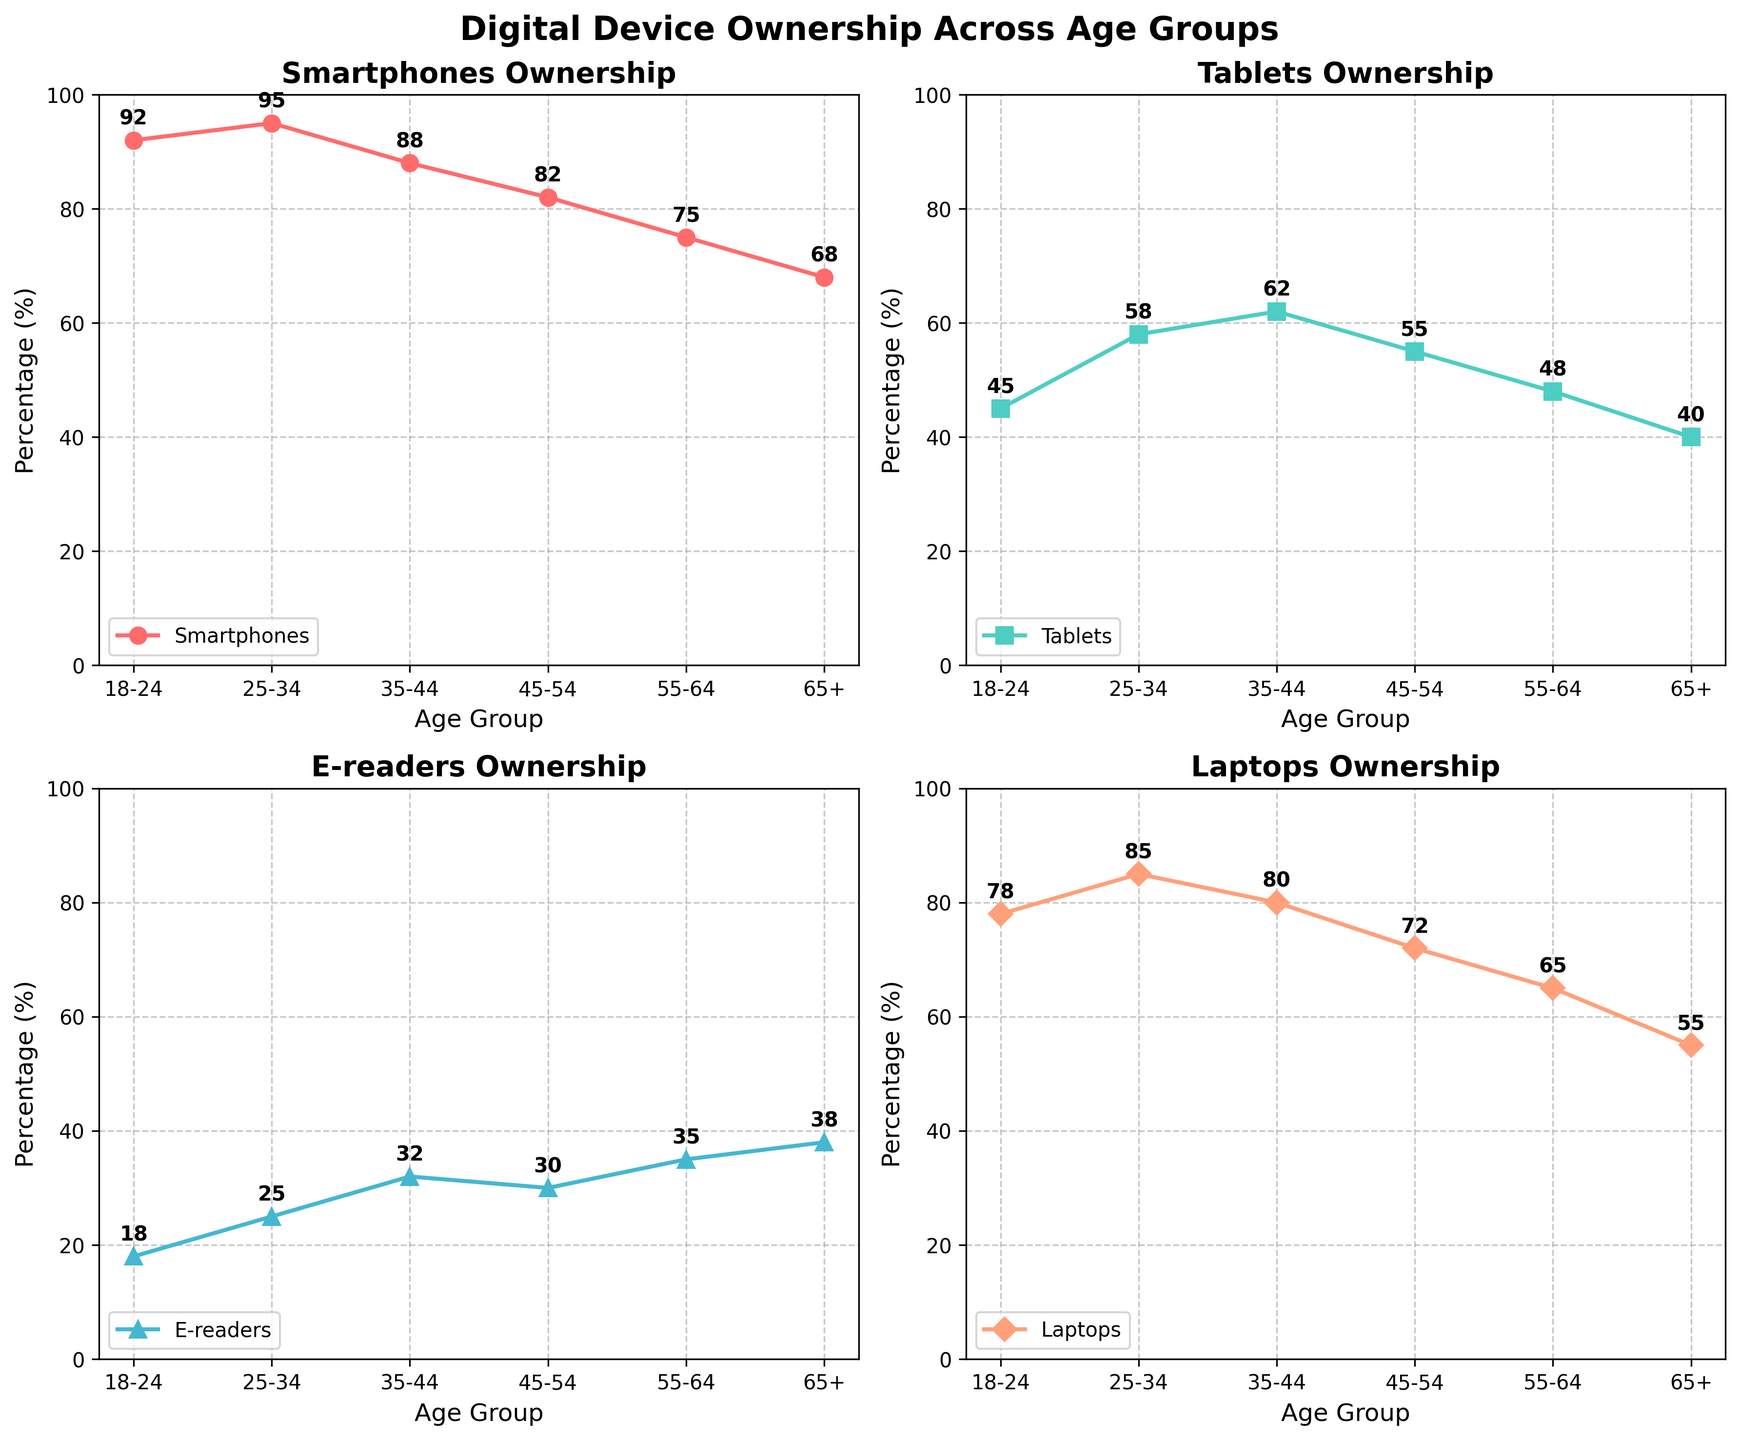What is the title of the figure? The title of the figure is located at the top center of the plot. It is in a larger and bold font compared to other text on the figure.
Answer: Digital Device Ownership Across Age Groups How many different age groups are represented in the plot? Count the distinct age groups listed along the x-axis of each subplot.
Answer: 6 Which age group has the highest percentage of smartphone ownership? Identify the age group with the highest data point in the smartphone subplot. This can be seen from the trend of the plot line.
Answer: 25-34 Which device has the smallest percentage of ownership in the 65+ age group? Examine the data points in the subplot corresponding to the 65+ age group in each of the subplots and find the smallest percentage value.
Answer: Smartphones Are there any age groups where the percentage of e-reader ownership is greater than laptop ownership? Compare each age group's e-reader and laptop ownership percentages to check if the e-reader percentage exceeds the laptop percentage.
Answer: Yes, 65+ age group Which device shows the least variation in ownership percentages across different age groups? Examine the range of percentages for each device across all age groups and identify the one with the smallest range.
Answer: E-readers 